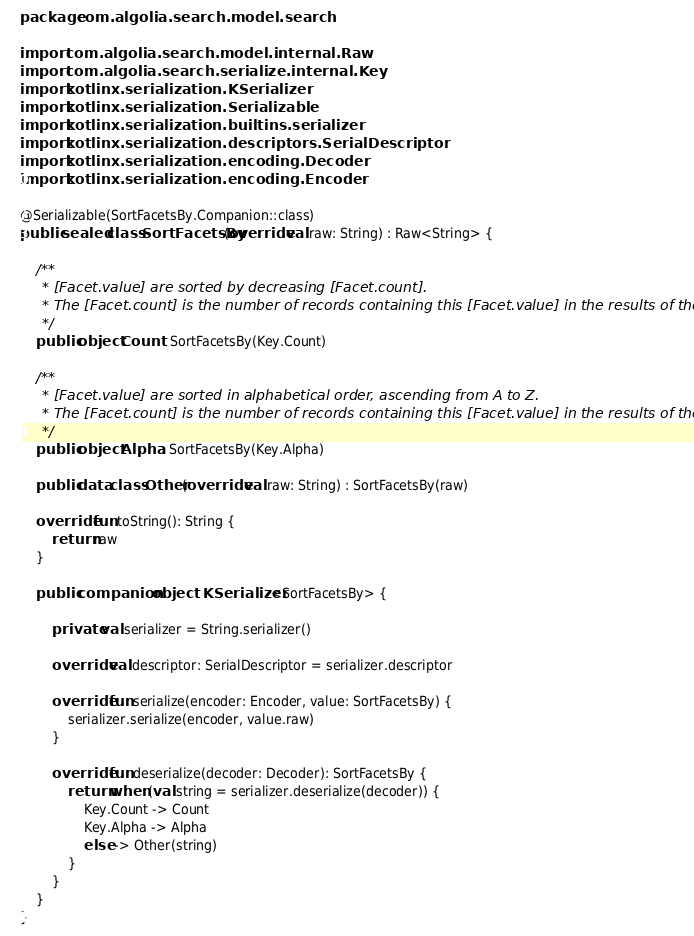Convert code to text. <code><loc_0><loc_0><loc_500><loc_500><_Kotlin_>package com.algolia.search.model.search

import com.algolia.search.model.internal.Raw
import com.algolia.search.serialize.internal.Key
import kotlinx.serialization.KSerializer
import kotlinx.serialization.Serializable
import kotlinx.serialization.builtins.serializer
import kotlinx.serialization.descriptors.SerialDescriptor
import kotlinx.serialization.encoding.Decoder
import kotlinx.serialization.encoding.Encoder

@Serializable(SortFacetsBy.Companion::class)
public sealed class SortFacetsBy(override val raw: String) : Raw<String> {

    /**
     * [Facet.value] are sorted by decreasing [Facet.count].
     * The [Facet.count] is the number of records containing this [Facet.value] in the results of the [Query].
     */
    public object Count : SortFacetsBy(Key.Count)

    /**
     * [Facet.value] are sorted in alphabetical order, ascending from A to Z.
     * The [Facet.count] is the number of records containing this [Facet.value] in the results of the [Query].
     */
    public object Alpha : SortFacetsBy(Key.Alpha)

    public data class Other(override val raw: String) : SortFacetsBy(raw)

    override fun toString(): String {
        return raw
    }

    public companion object : KSerializer<SortFacetsBy> {

        private val serializer = String.serializer()

        override val descriptor: SerialDescriptor = serializer.descriptor

        override fun serialize(encoder: Encoder, value: SortFacetsBy) {
            serializer.serialize(encoder, value.raw)
        }

        override fun deserialize(decoder: Decoder): SortFacetsBy {
            return when (val string = serializer.deserialize(decoder)) {
                Key.Count -> Count
                Key.Alpha -> Alpha
                else -> Other(string)
            }
        }
    }
}
</code> 